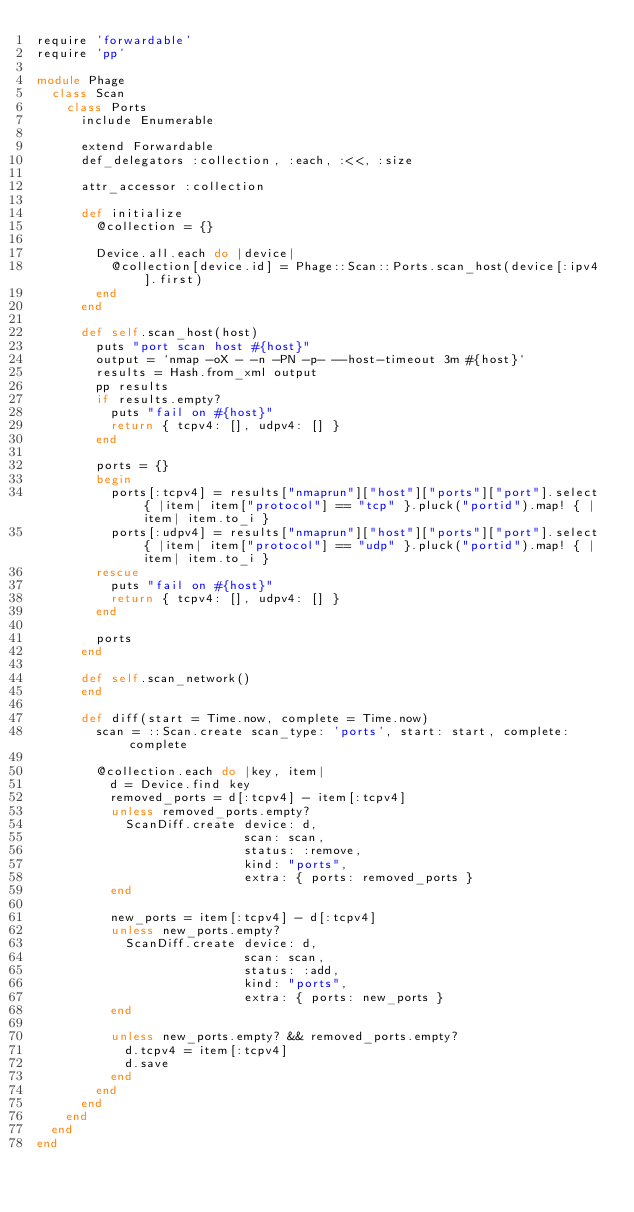<code> <loc_0><loc_0><loc_500><loc_500><_Ruby_>require 'forwardable'
require 'pp'

module Phage
  class Scan
    class Ports
      include Enumerable

      extend Forwardable
      def_delegators :collection, :each, :<<, :size

      attr_accessor :collection
      
      def initialize
        @collection = {}

        Device.all.each do |device|
          @collection[device.id] = Phage::Scan::Ports.scan_host(device[:ipv4].first)
        end
      end

      def self.scan_host(host)
        puts "port scan host #{host}"
        output = `nmap -oX - -n -PN -p- --host-timeout 3m #{host}`
        results = Hash.from_xml output
        pp results
        if results.empty?
          puts "fail on #{host}"
          return { tcpv4: [], udpv4: [] }
        end

        ports = {}
        begin
          ports[:tcpv4] = results["nmaprun"]["host"]["ports"]["port"].select { |item| item["protocol"] == "tcp" }.pluck("portid").map! { |item| item.to_i }
          ports[:udpv4] = results["nmaprun"]["host"]["ports"]["port"].select { |item| item["protocol"] == "udp" }.pluck("portid").map! { |item| item.to_i }
        rescue
          puts "fail on #{host}"
          return { tcpv4: [], udpv4: [] }
        end

        ports
      end

      def self.scan_network()
      end

      def diff(start = Time.now, complete = Time.now)
        scan = ::Scan.create scan_type: 'ports', start: start, complete: complete

        @collection.each do |key, item|
          d = Device.find key
          removed_ports = d[:tcpv4] - item[:tcpv4]
          unless removed_ports.empty?
            ScanDiff.create device: d,
                            scan: scan,
                            status: :remove,
                            kind: "ports",
                            extra: { ports: removed_ports }
          end

          new_ports = item[:tcpv4] - d[:tcpv4]
          unless new_ports.empty?
            ScanDiff.create device: d,
                            scan: scan,
                            status: :add,
                            kind: "ports",
                            extra: { ports: new_ports }
          end

          unless new_ports.empty? && removed_ports.empty?
            d.tcpv4 = item[:tcpv4]
            d.save
          end
        end
      end
    end
  end
end
</code> 